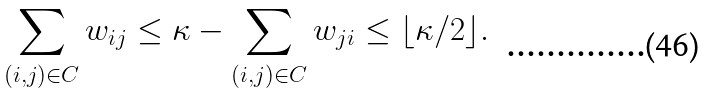<formula> <loc_0><loc_0><loc_500><loc_500>\sum _ { ( i , j ) \in C } w _ { i j } \leq \kappa - \sum _ { ( i , j ) \in C } w _ { j i } \leq \lfloor { \kappa / 2 } \rfloor .</formula> 